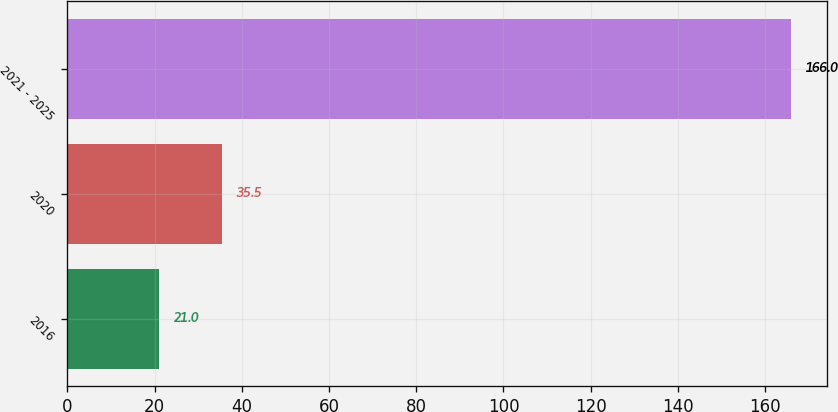Convert chart to OTSL. <chart><loc_0><loc_0><loc_500><loc_500><bar_chart><fcel>2016<fcel>2020<fcel>2021 - 2025<nl><fcel>21<fcel>35.5<fcel>166<nl></chart> 